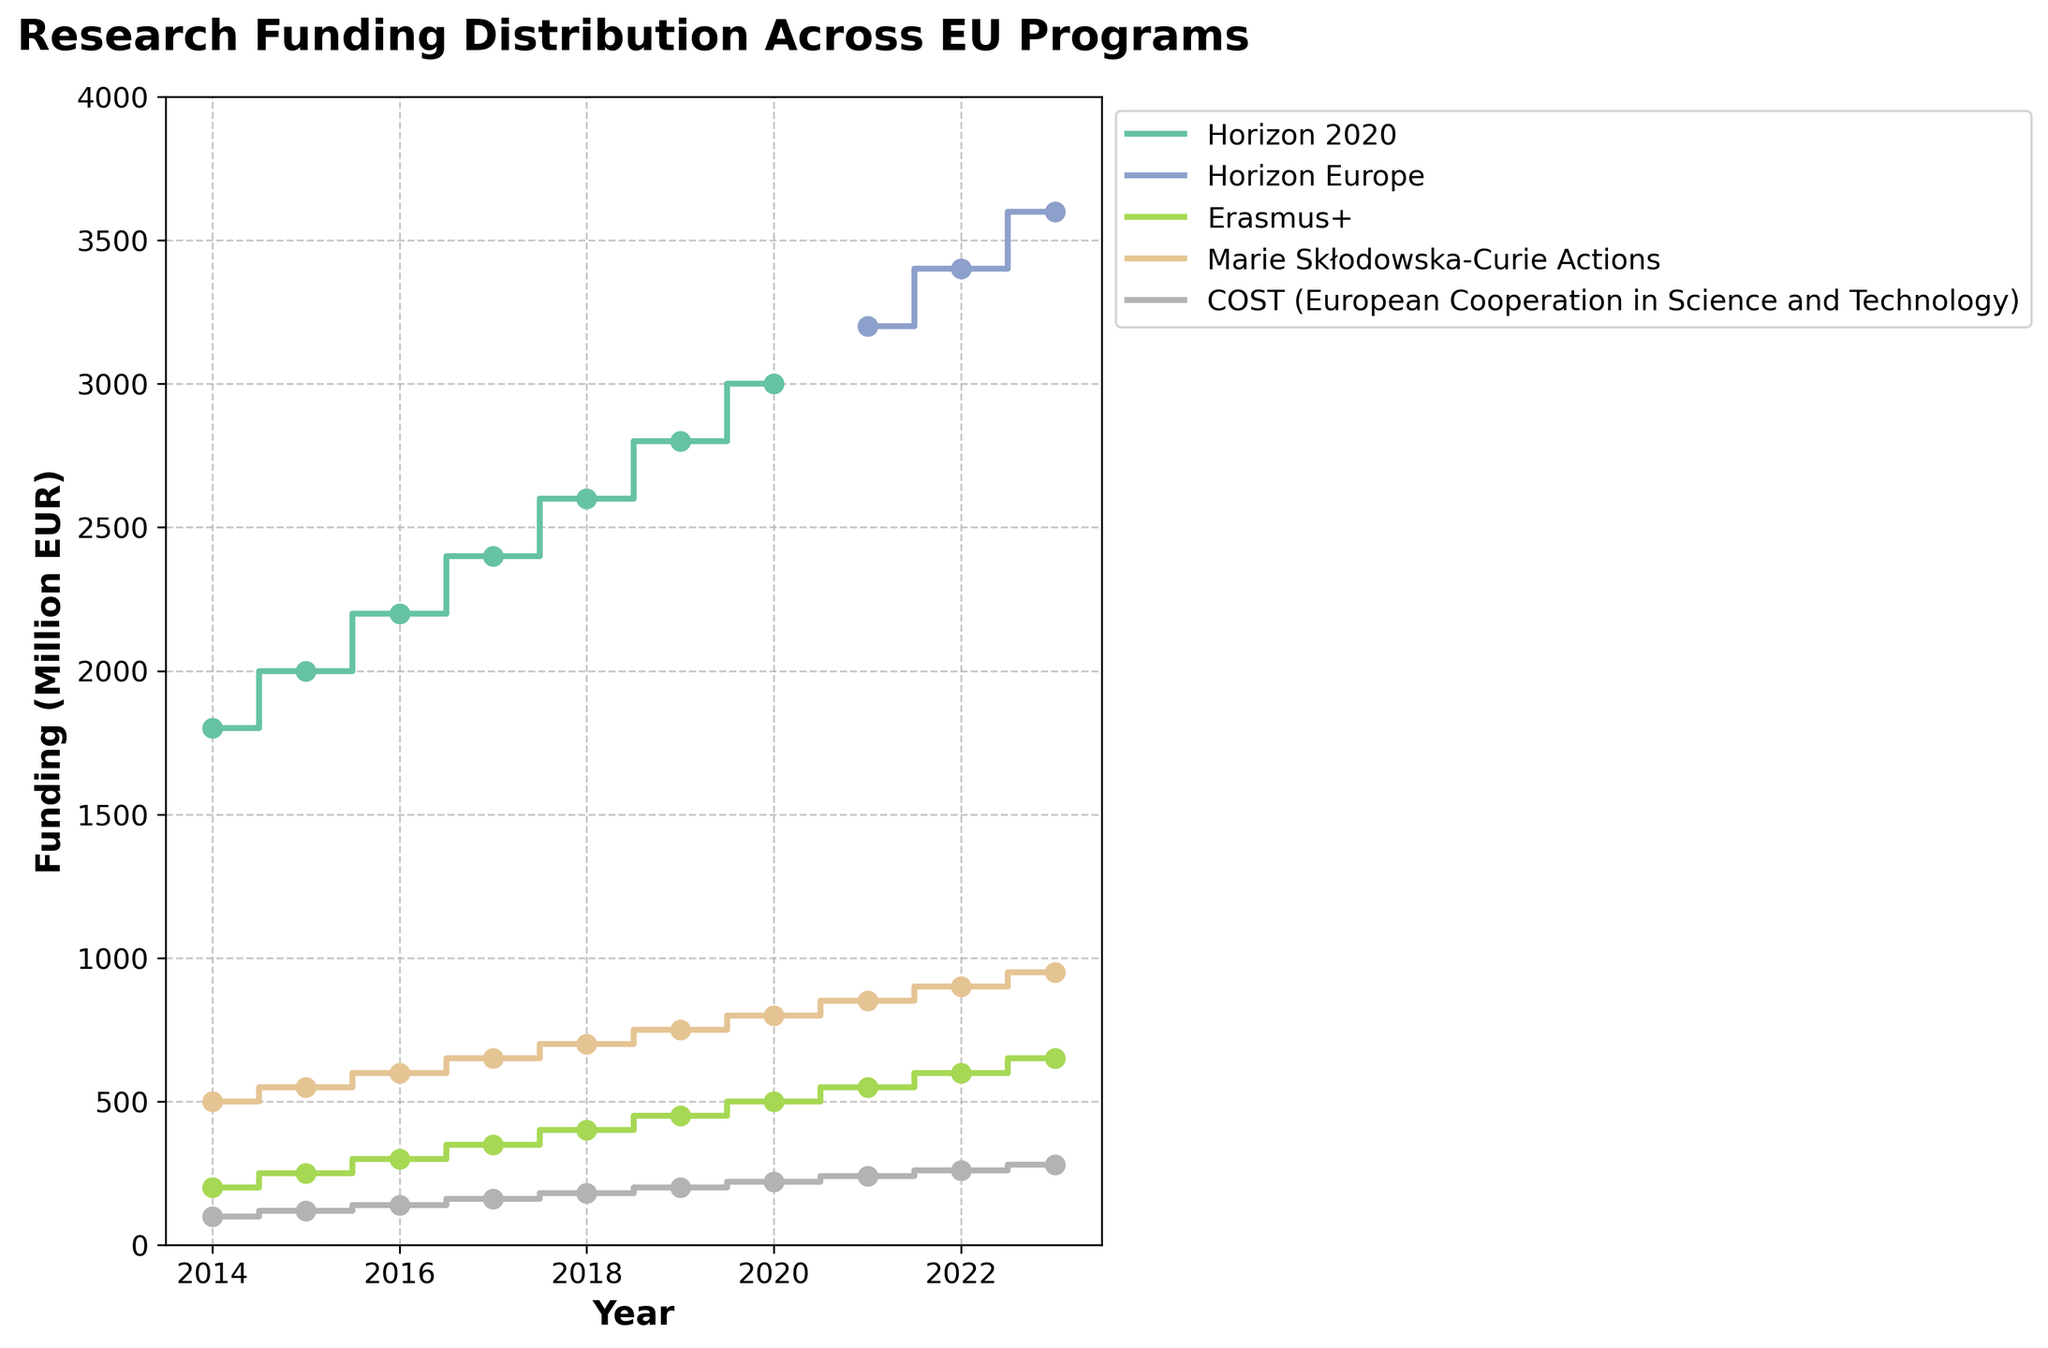What's the title of the figure? Look at the top of the plot to find the title.
Answer: Research Funding Distribution Across EU Programs How does the funding for Horizon 2020 change from 2014 to 2020? Observe the stair steps for Horizon 2020, noting that the funding increases each year. In 2014, it starts at 1800 million EUR and reaches 3000 million EUR in 2020.
Answer: It increases each year Which program received the most funding in 2023? Check which program has the highest funding value on the y-axis for the year 2023. Horizon Europe has the highest value at 3600 million EUR.
Answer: Horizon Europe What is the total funding for Erasmus+ over the last decade? Sum up the funding values for Erasmus+ from 2014 to 2023: 200 + 250 + 300 + 350 + 400 + 450 + 500 + 550 + 600 + 650. The sum is 4250 million EUR.
Answer: 4250 million EUR Which program had the smallest increase in funding over the decade? Compare the differences between the initial and final funding values for each program. COST (European Cooperation in Science and Technology) has an increase from 100 to 280 million EUR, the smallest change among the programs.
Answer: COST (280 - 100 = 180 million EUR) In which year did Horizon Europe first appear in the plot? Look for the first stair-step and scatter point for Horizon Europe, which starts in 2021.
Answer: 2021 How did the funding for Marie Skłodowska-Curie Actions change from 2014 to 2023? Observe the stair steps for Marie Skłodowska-Curie Actions, and note that the funding increases each year. In 2014 it starts at 500 million EUR and reaches 950 million EUR in 2023.
Answer: It increases each year Compare the funding between Horizon 2020 and Erasmus+ in 2016. Refer to the stair steps and scatter points for 2016. Horizon 2020 has 2200 million EUR and Erasmus+ has 300 million EUR.
Answer: Horizon 2020 has significantly more What can you say about the funding evolution for COST between 2014 and 2023? The stair-step for COST shows a steady and gradual increase each year, starting at 100 million EUR in 2014 and ending at 280 million EUR in 2023.
Answer: Steady increase Calculate the average annual funding for Horizon Europe from 2021 to 2023. Sum the funding values for Horizon Europe from 2021 to 2023: 3200 + 3400 + 3600. The sum is 10200. There are 3 years, so 10200 / 3 = 3400 million EUR.
Answer: 3400 million EUR 